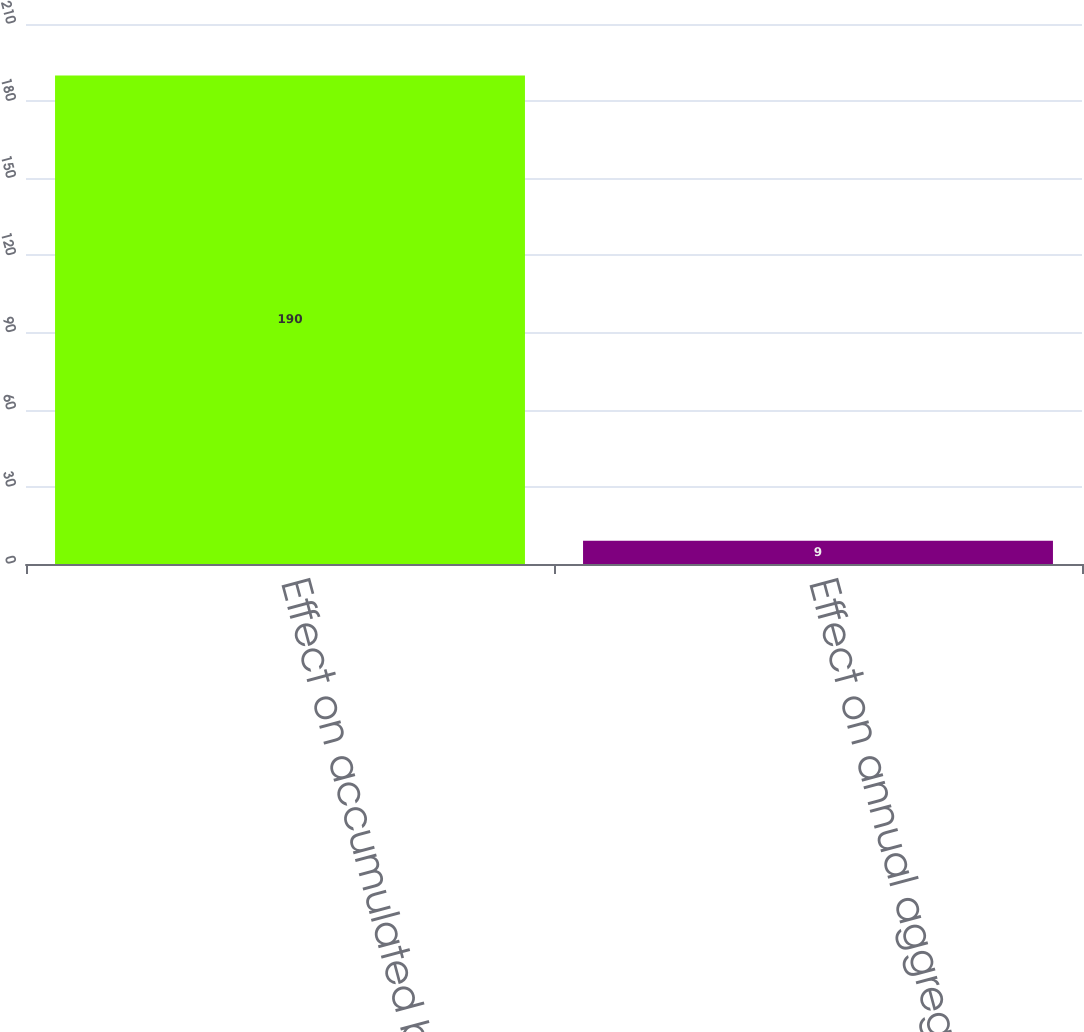Convert chart to OTSL. <chart><loc_0><loc_0><loc_500><loc_500><bar_chart><fcel>Effect on accumulated benefit<fcel>Effect on annual aggregate<nl><fcel>190<fcel>9<nl></chart> 